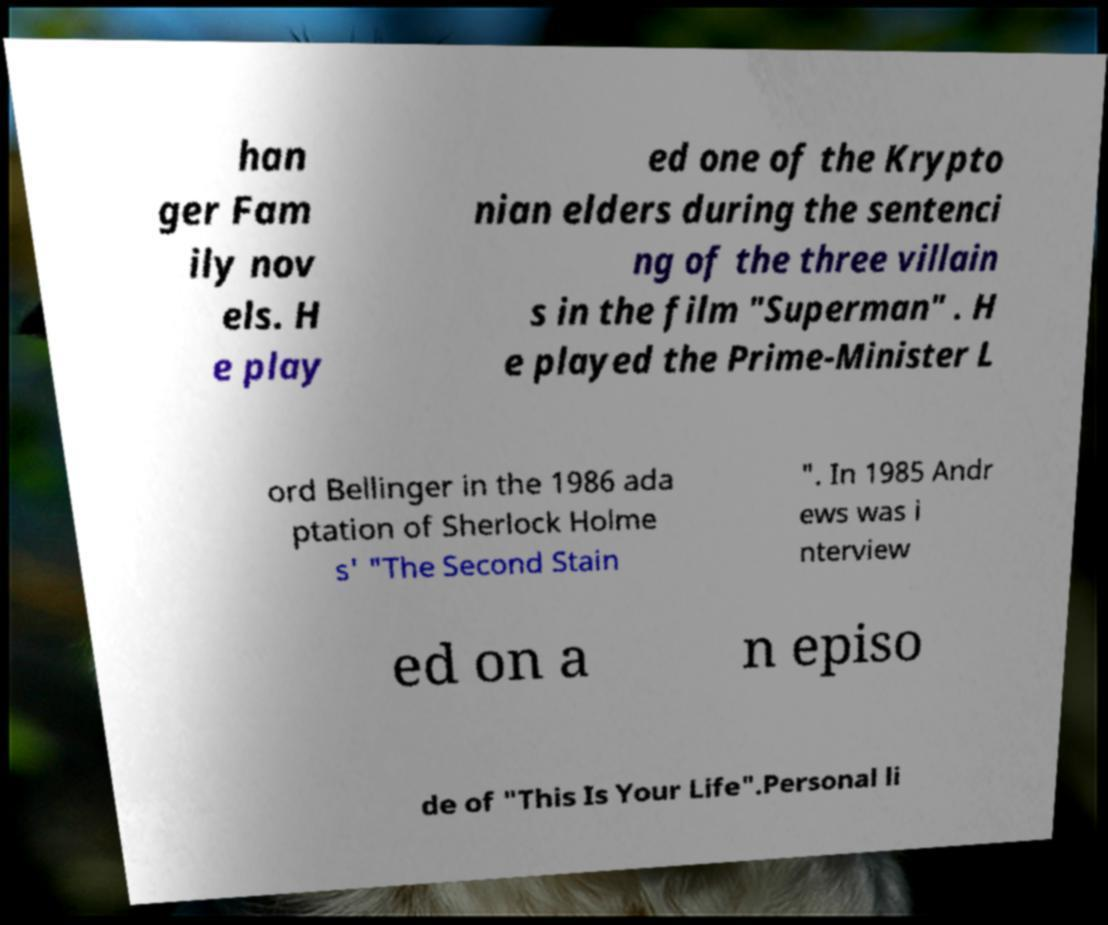Please read and relay the text visible in this image. What does it say? han ger Fam ily nov els. H e play ed one of the Krypto nian elders during the sentenci ng of the three villain s in the film "Superman" . H e played the Prime-Minister L ord Bellinger in the 1986 ada ptation of Sherlock Holme s' "The Second Stain ". In 1985 Andr ews was i nterview ed on a n episo de of "This Is Your Life".Personal li 